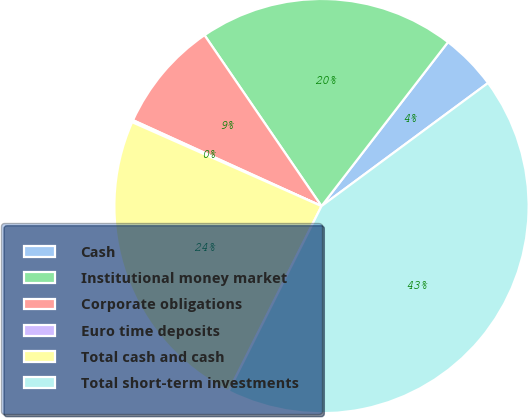Convert chart to OTSL. <chart><loc_0><loc_0><loc_500><loc_500><pie_chart><fcel>Cash<fcel>Institutional money market<fcel>Corporate obligations<fcel>Euro time deposits<fcel>Total cash and cash<fcel>Total short-term investments<nl><fcel>4.41%<fcel>20.01%<fcel>8.64%<fcel>0.17%<fcel>24.24%<fcel>42.53%<nl></chart> 